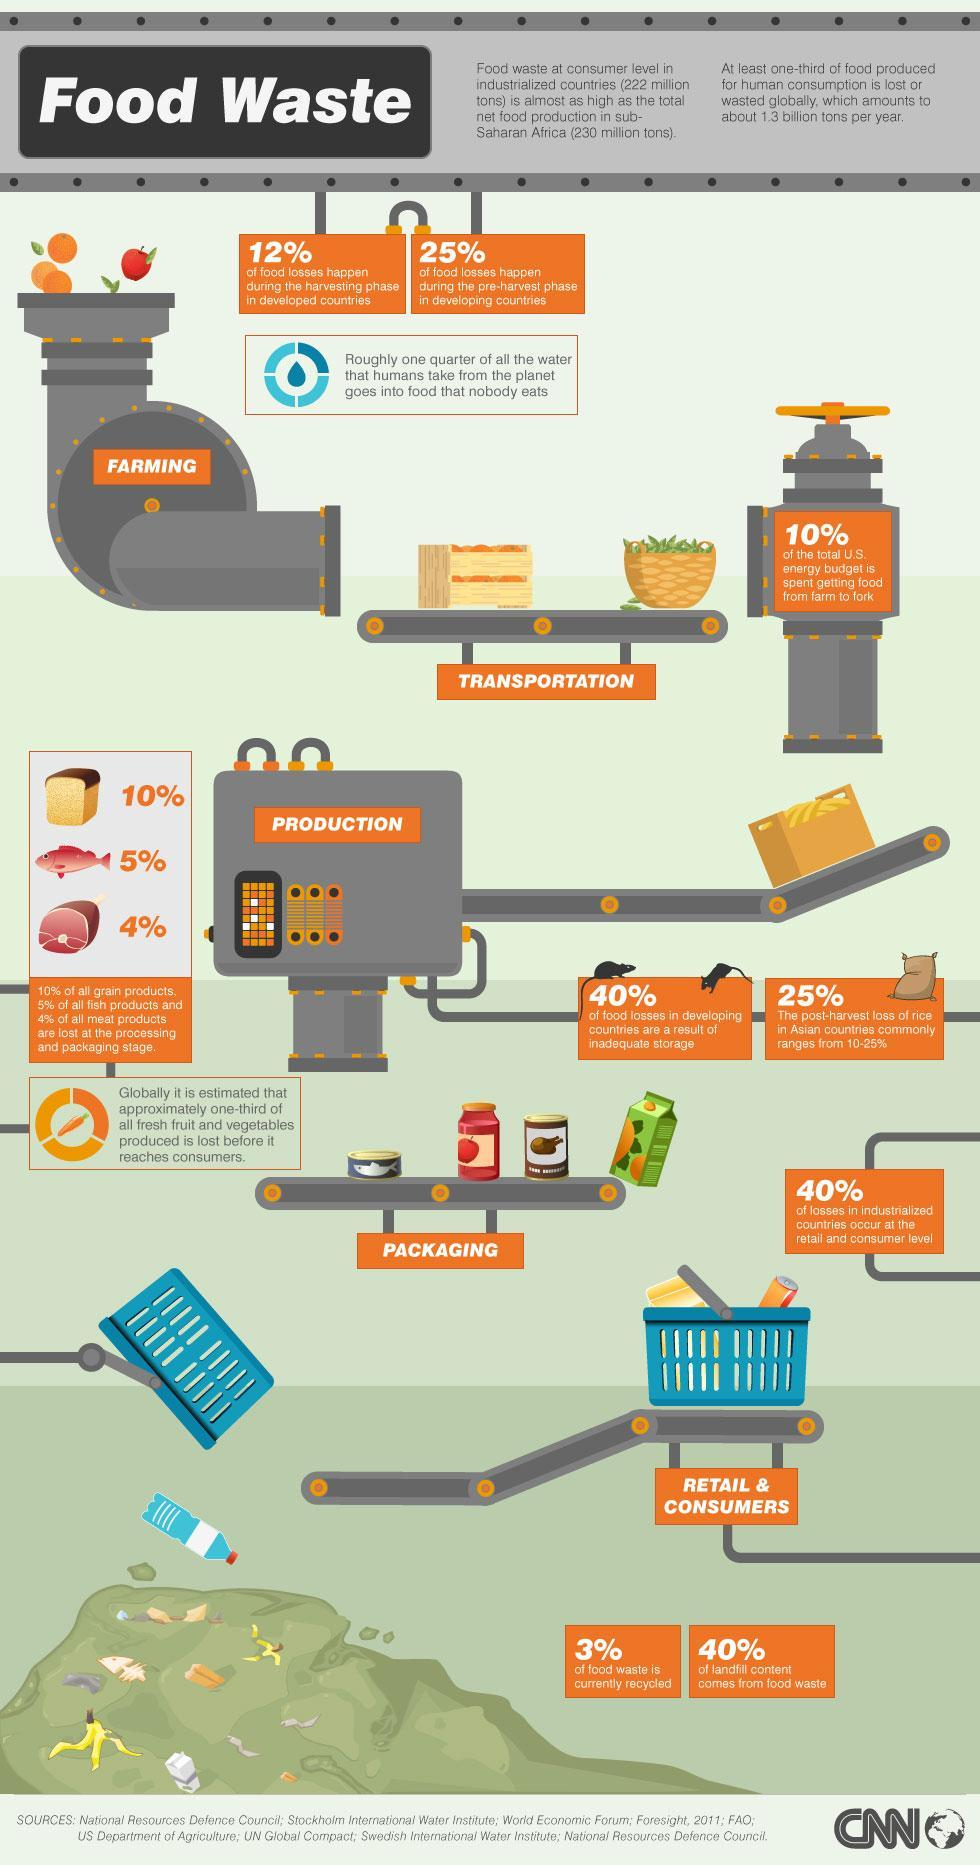What percentage of landfill content do not come from food waste in developing countries?
Answer the question with a short phrase. 60% What percentage of food waste in developing countries are not recycled currently? 77% What percentage of food losses do not happen during the harvesting phase in developed countries? 88% What percentage of food losses in developing countries are not as a result of inadequate storage? 60% 